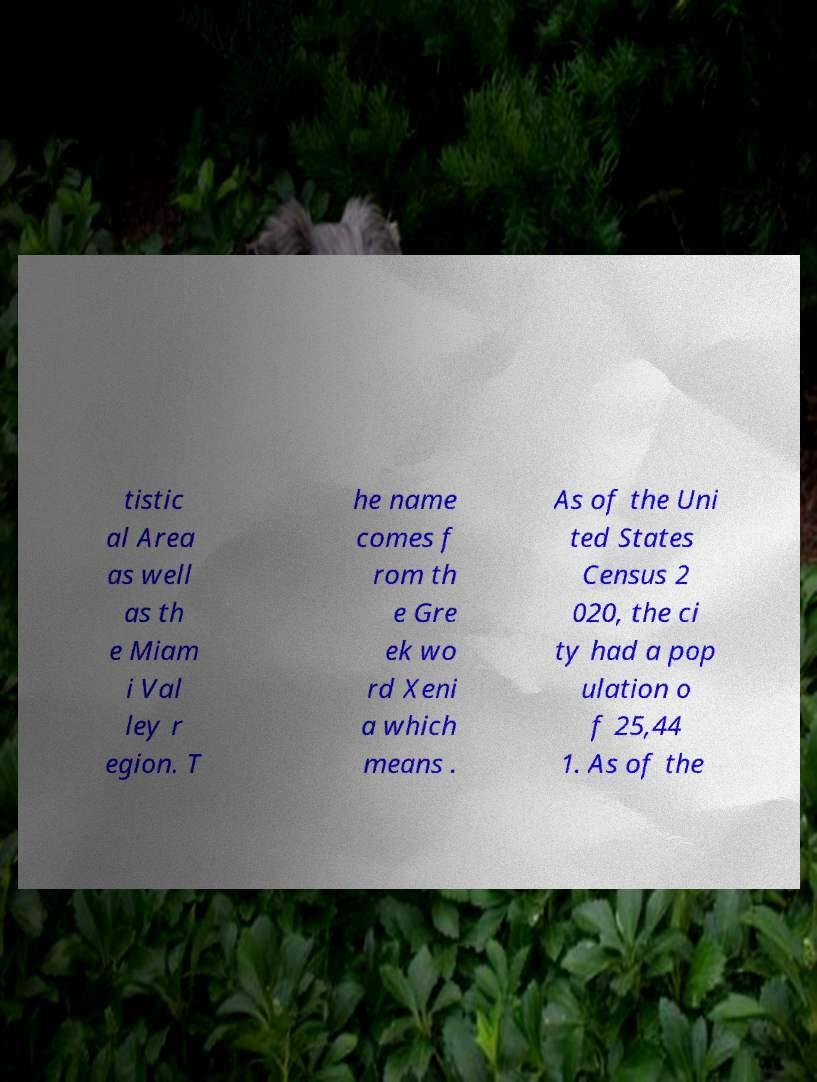I need the written content from this picture converted into text. Can you do that? tistic al Area as well as th e Miam i Val ley r egion. T he name comes f rom th e Gre ek wo rd Xeni a which means . As of the Uni ted States Census 2 020, the ci ty had a pop ulation o f 25,44 1. As of the 